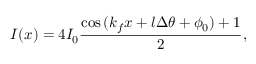Convert formula to latex. <formula><loc_0><loc_0><loc_500><loc_500>I ( x ) = 4 I _ { 0 } \frac { \cos { ( k _ { f } x + l \Delta \theta + \phi _ { 0 } ) } + 1 } { 2 } ,</formula> 